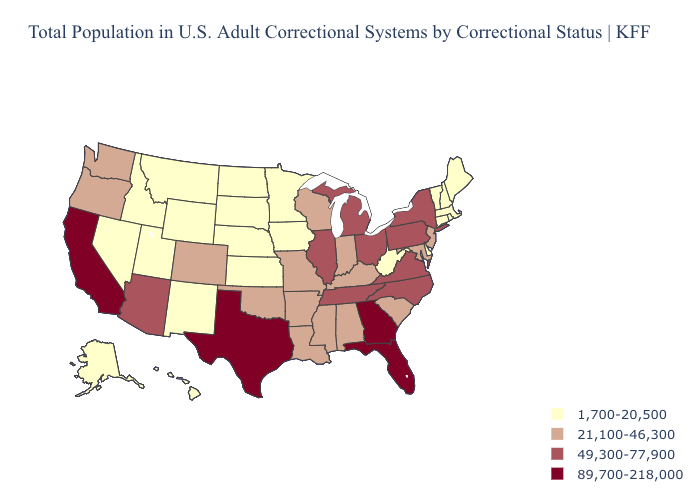Which states have the lowest value in the USA?
Answer briefly. Alaska, Connecticut, Delaware, Hawaii, Idaho, Iowa, Kansas, Maine, Massachusetts, Minnesota, Montana, Nebraska, Nevada, New Hampshire, New Mexico, North Dakota, Rhode Island, South Dakota, Utah, Vermont, West Virginia, Wyoming. What is the value of Texas?
Concise answer only. 89,700-218,000. Which states have the lowest value in the USA?
Give a very brief answer. Alaska, Connecticut, Delaware, Hawaii, Idaho, Iowa, Kansas, Maine, Massachusetts, Minnesota, Montana, Nebraska, Nevada, New Hampshire, New Mexico, North Dakota, Rhode Island, South Dakota, Utah, Vermont, West Virginia, Wyoming. What is the lowest value in the South?
Be succinct. 1,700-20,500. Does the first symbol in the legend represent the smallest category?
Answer briefly. Yes. Does Minnesota have the highest value in the MidWest?
Answer briefly. No. Name the states that have a value in the range 89,700-218,000?
Give a very brief answer. California, Florida, Georgia, Texas. Name the states that have a value in the range 89,700-218,000?
Short answer required. California, Florida, Georgia, Texas. Does South Carolina have the lowest value in the USA?
Keep it brief. No. Among the states that border Oregon , does Idaho have the lowest value?
Be succinct. Yes. What is the highest value in the USA?
Write a very short answer. 89,700-218,000. Does the first symbol in the legend represent the smallest category?
Keep it brief. Yes. What is the value of New Mexico?
Short answer required. 1,700-20,500. Name the states that have a value in the range 49,300-77,900?
Give a very brief answer. Arizona, Illinois, Michigan, New York, North Carolina, Ohio, Pennsylvania, Tennessee, Virginia. What is the value of South Carolina?
Short answer required. 21,100-46,300. 